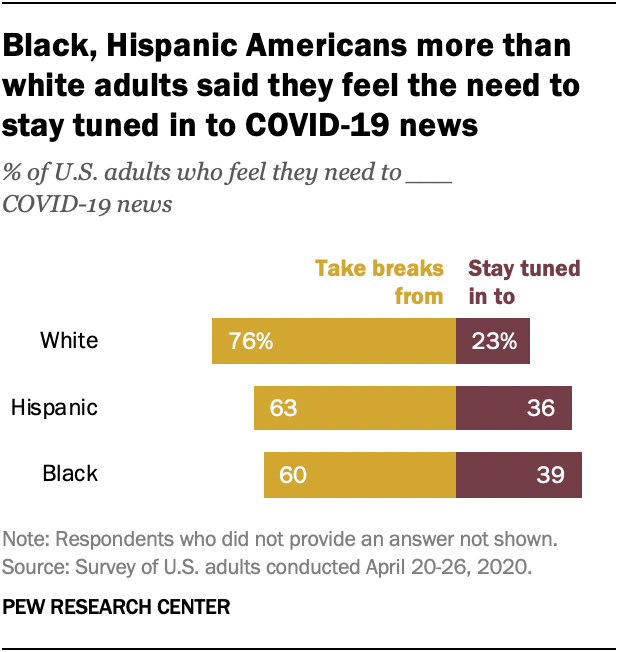Highlight a few significant elements in this photo. Approximately 0.01% of white people have no answer or a different answer than "take breaks from" or "stay tuned in to" regarding a popular TV show. 